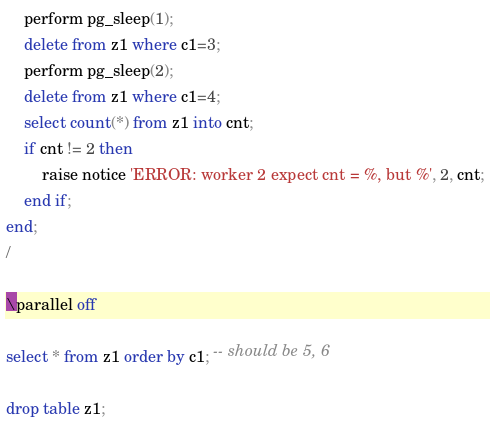Convert code to text. <code><loc_0><loc_0><loc_500><loc_500><_SQL_>	perform pg_sleep(1);
	delete from z1 where c1=3;
	perform pg_sleep(2);
	delete from z1 where c1=4;
	select count(*) from z1 into cnt;
	if cnt != 2 then
		raise notice 'ERROR: worker 2 expect cnt = %, but %', 2, cnt;
	end if;
end;
/

\parallel off

select * from z1 order by c1; -- should be 5, 6

drop table z1;


</code> 